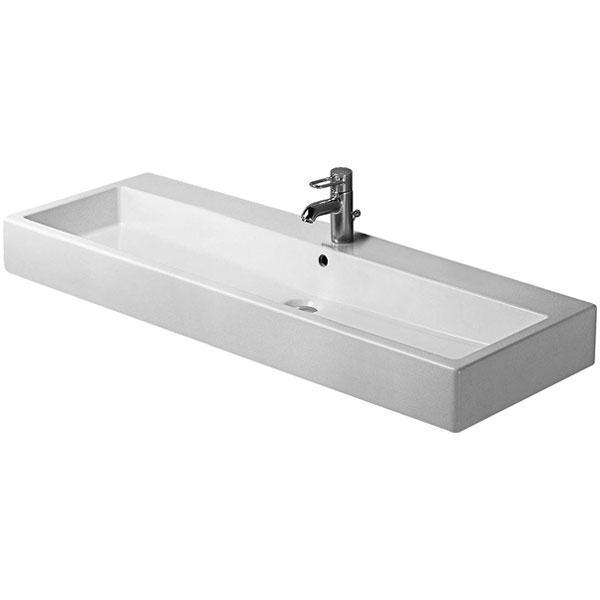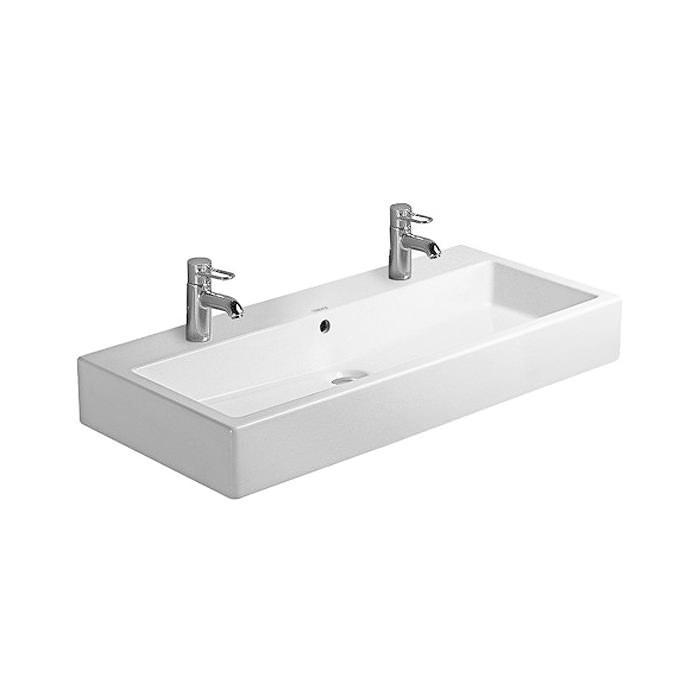The first image is the image on the left, the second image is the image on the right. Assess this claim about the two images: "There are two drains visible.". Correct or not? Answer yes or no. Yes. 